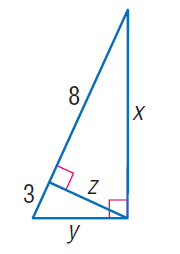Question: Find y.
Choices:
A. 2 \sqrt { 6 }
B. \sqrt { 33 }
C. \sqrt { 34 }
D. 2 \sqrt { 11 }
Answer with the letter. Answer: B Question: Find x.
Choices:
A. \sqrt { 24 }
B. 2 \sqrt { 11 }
C. 2 \sqrt { 22 }
D. \sqrt { 89 }
Answer with the letter. Answer: C 